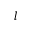Convert formula to latex. <formula><loc_0><loc_0><loc_500><loc_500>l</formula> 